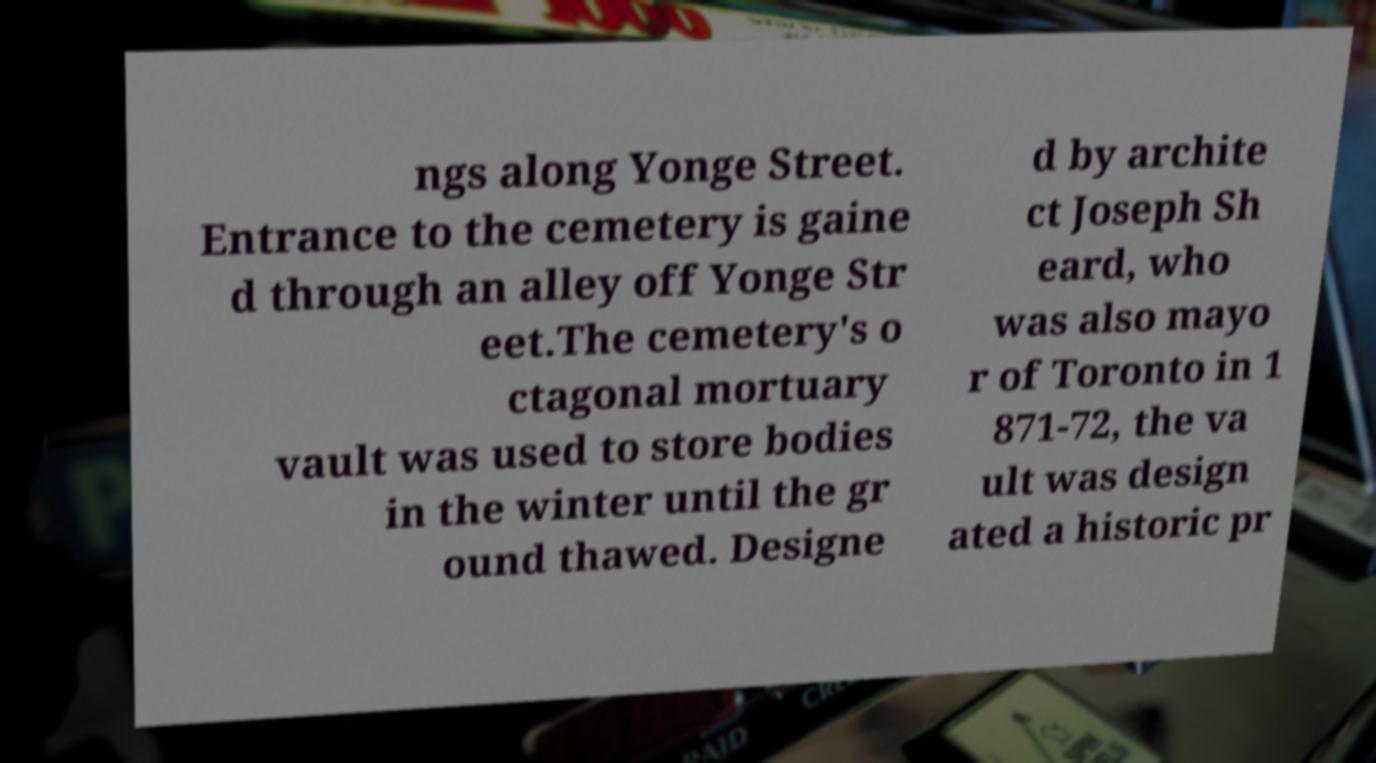Can you accurately transcribe the text from the provided image for me? ngs along Yonge Street. Entrance to the cemetery is gaine d through an alley off Yonge Str eet.The cemetery's o ctagonal mortuary vault was used to store bodies in the winter until the gr ound thawed. Designe d by archite ct Joseph Sh eard, who was also mayo r of Toronto in 1 871-72, the va ult was design ated a historic pr 